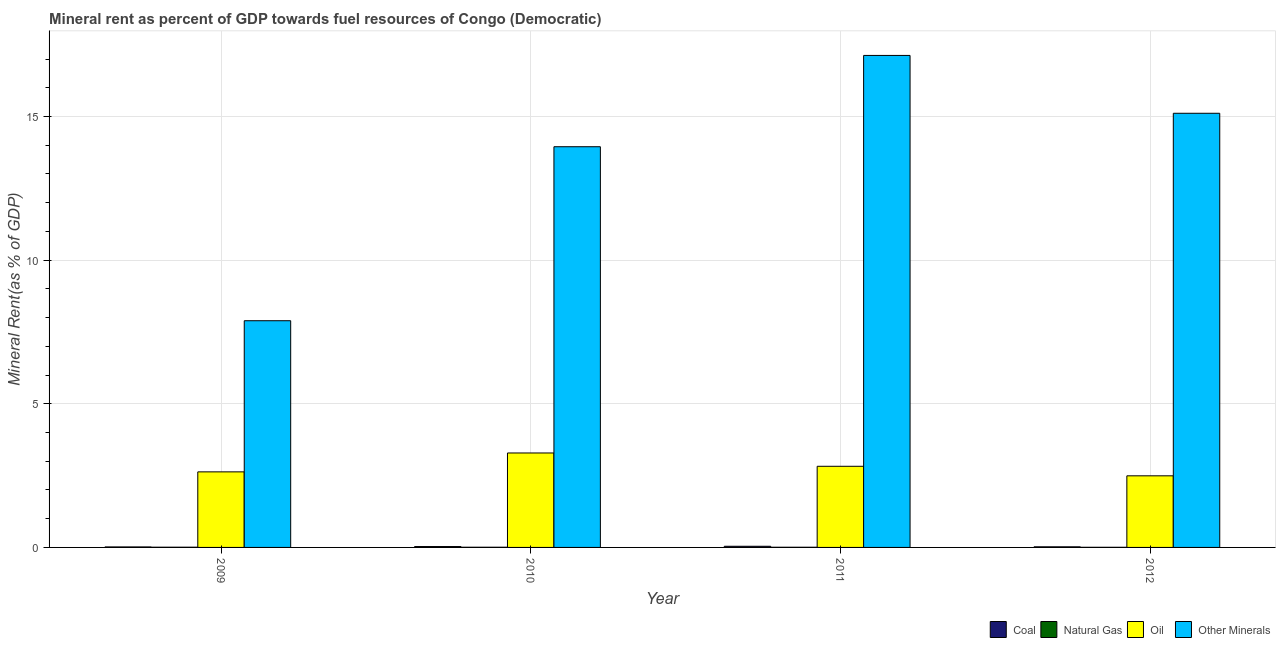How many different coloured bars are there?
Your answer should be very brief. 4. How many groups of bars are there?
Provide a succinct answer. 4. How many bars are there on the 2nd tick from the left?
Your response must be concise. 4. How many bars are there on the 2nd tick from the right?
Your answer should be compact. 4. What is the label of the 1st group of bars from the left?
Offer a terse response. 2009. In how many cases, is the number of bars for a given year not equal to the number of legend labels?
Your response must be concise. 0. What is the oil rent in 2009?
Your response must be concise. 2.63. Across all years, what is the maximum natural gas rent?
Provide a short and direct response. 0.01. Across all years, what is the minimum natural gas rent?
Your response must be concise. 0. In which year was the  rent of other minerals maximum?
Offer a terse response. 2011. What is the total oil rent in the graph?
Your response must be concise. 11.23. What is the difference between the oil rent in 2011 and that in 2012?
Make the answer very short. 0.33. What is the difference between the natural gas rent in 2012 and the oil rent in 2011?
Make the answer very short. -0. What is the average natural gas rent per year?
Your answer should be compact. 0.01. What is the ratio of the natural gas rent in 2010 to that in 2012?
Ensure brevity in your answer.  1.4. What is the difference between the highest and the second highest oil rent?
Give a very brief answer. 0.46. What is the difference between the highest and the lowest natural gas rent?
Provide a short and direct response. 0. Is the sum of the  rent of other minerals in 2009 and 2010 greater than the maximum coal rent across all years?
Offer a terse response. Yes. Is it the case that in every year, the sum of the oil rent and natural gas rent is greater than the sum of  rent of other minerals and coal rent?
Your answer should be compact. Yes. What does the 2nd bar from the left in 2010 represents?
Provide a succinct answer. Natural Gas. What does the 1st bar from the right in 2009 represents?
Offer a terse response. Other Minerals. Are all the bars in the graph horizontal?
Ensure brevity in your answer.  No. What is the difference between two consecutive major ticks on the Y-axis?
Your answer should be very brief. 5. Are the values on the major ticks of Y-axis written in scientific E-notation?
Your answer should be compact. No. Does the graph contain grids?
Offer a very short reply. Yes. How many legend labels are there?
Your answer should be very brief. 4. How are the legend labels stacked?
Your answer should be compact. Horizontal. What is the title of the graph?
Provide a succinct answer. Mineral rent as percent of GDP towards fuel resources of Congo (Democratic). Does "Debt policy" appear as one of the legend labels in the graph?
Provide a short and direct response. No. What is the label or title of the Y-axis?
Your response must be concise. Mineral Rent(as % of GDP). What is the Mineral Rent(as % of GDP) of Coal in 2009?
Make the answer very short. 0.02. What is the Mineral Rent(as % of GDP) in Natural Gas in 2009?
Offer a very short reply. 0.01. What is the Mineral Rent(as % of GDP) in Oil in 2009?
Your response must be concise. 2.63. What is the Mineral Rent(as % of GDP) of Other Minerals in 2009?
Keep it short and to the point. 7.89. What is the Mineral Rent(as % of GDP) in Coal in 2010?
Provide a short and direct response. 0.03. What is the Mineral Rent(as % of GDP) in Natural Gas in 2010?
Keep it short and to the point. 0.01. What is the Mineral Rent(as % of GDP) of Oil in 2010?
Provide a succinct answer. 3.29. What is the Mineral Rent(as % of GDP) in Other Minerals in 2010?
Your answer should be very brief. 13.95. What is the Mineral Rent(as % of GDP) of Coal in 2011?
Provide a succinct answer. 0.04. What is the Mineral Rent(as % of GDP) of Natural Gas in 2011?
Make the answer very short. 0.01. What is the Mineral Rent(as % of GDP) in Oil in 2011?
Keep it short and to the point. 2.82. What is the Mineral Rent(as % of GDP) of Other Minerals in 2011?
Offer a very short reply. 17.13. What is the Mineral Rent(as % of GDP) in Coal in 2012?
Give a very brief answer. 0.02. What is the Mineral Rent(as % of GDP) of Natural Gas in 2012?
Make the answer very short. 0. What is the Mineral Rent(as % of GDP) in Oil in 2012?
Give a very brief answer. 2.49. What is the Mineral Rent(as % of GDP) in Other Minerals in 2012?
Provide a succinct answer. 15.11. Across all years, what is the maximum Mineral Rent(as % of GDP) in Coal?
Offer a very short reply. 0.04. Across all years, what is the maximum Mineral Rent(as % of GDP) in Natural Gas?
Provide a short and direct response. 0.01. Across all years, what is the maximum Mineral Rent(as % of GDP) of Oil?
Make the answer very short. 3.29. Across all years, what is the maximum Mineral Rent(as % of GDP) of Other Minerals?
Your answer should be very brief. 17.13. Across all years, what is the minimum Mineral Rent(as % of GDP) in Coal?
Provide a short and direct response. 0.02. Across all years, what is the minimum Mineral Rent(as % of GDP) in Natural Gas?
Offer a very short reply. 0. Across all years, what is the minimum Mineral Rent(as % of GDP) in Oil?
Offer a very short reply. 2.49. Across all years, what is the minimum Mineral Rent(as % of GDP) in Other Minerals?
Ensure brevity in your answer.  7.89. What is the total Mineral Rent(as % of GDP) in Coal in the graph?
Offer a very short reply. 0.11. What is the total Mineral Rent(as % of GDP) in Natural Gas in the graph?
Provide a succinct answer. 0.02. What is the total Mineral Rent(as % of GDP) of Oil in the graph?
Make the answer very short. 11.23. What is the total Mineral Rent(as % of GDP) of Other Minerals in the graph?
Your answer should be very brief. 54.08. What is the difference between the Mineral Rent(as % of GDP) of Coal in 2009 and that in 2010?
Give a very brief answer. -0.01. What is the difference between the Mineral Rent(as % of GDP) in Natural Gas in 2009 and that in 2010?
Your answer should be compact. 0. What is the difference between the Mineral Rent(as % of GDP) of Oil in 2009 and that in 2010?
Your response must be concise. -0.66. What is the difference between the Mineral Rent(as % of GDP) of Other Minerals in 2009 and that in 2010?
Keep it short and to the point. -6.06. What is the difference between the Mineral Rent(as % of GDP) in Coal in 2009 and that in 2011?
Provide a short and direct response. -0.02. What is the difference between the Mineral Rent(as % of GDP) of Natural Gas in 2009 and that in 2011?
Offer a terse response. 0. What is the difference between the Mineral Rent(as % of GDP) in Oil in 2009 and that in 2011?
Offer a terse response. -0.19. What is the difference between the Mineral Rent(as % of GDP) of Other Minerals in 2009 and that in 2011?
Your answer should be compact. -9.24. What is the difference between the Mineral Rent(as % of GDP) in Coal in 2009 and that in 2012?
Make the answer very short. -0. What is the difference between the Mineral Rent(as % of GDP) in Natural Gas in 2009 and that in 2012?
Ensure brevity in your answer.  0. What is the difference between the Mineral Rent(as % of GDP) in Oil in 2009 and that in 2012?
Provide a succinct answer. 0.14. What is the difference between the Mineral Rent(as % of GDP) in Other Minerals in 2009 and that in 2012?
Make the answer very short. -7.22. What is the difference between the Mineral Rent(as % of GDP) in Coal in 2010 and that in 2011?
Offer a terse response. -0.01. What is the difference between the Mineral Rent(as % of GDP) of Natural Gas in 2010 and that in 2011?
Give a very brief answer. 0. What is the difference between the Mineral Rent(as % of GDP) of Oil in 2010 and that in 2011?
Provide a short and direct response. 0.46. What is the difference between the Mineral Rent(as % of GDP) of Other Minerals in 2010 and that in 2011?
Your response must be concise. -3.18. What is the difference between the Mineral Rent(as % of GDP) of Coal in 2010 and that in 2012?
Give a very brief answer. 0.01. What is the difference between the Mineral Rent(as % of GDP) in Natural Gas in 2010 and that in 2012?
Provide a succinct answer. 0. What is the difference between the Mineral Rent(as % of GDP) in Oil in 2010 and that in 2012?
Make the answer very short. 0.8. What is the difference between the Mineral Rent(as % of GDP) in Other Minerals in 2010 and that in 2012?
Keep it short and to the point. -1.16. What is the difference between the Mineral Rent(as % of GDP) in Coal in 2011 and that in 2012?
Make the answer very short. 0.02. What is the difference between the Mineral Rent(as % of GDP) in Natural Gas in 2011 and that in 2012?
Ensure brevity in your answer.  0. What is the difference between the Mineral Rent(as % of GDP) of Oil in 2011 and that in 2012?
Ensure brevity in your answer.  0.33. What is the difference between the Mineral Rent(as % of GDP) of Other Minerals in 2011 and that in 2012?
Your response must be concise. 2.01. What is the difference between the Mineral Rent(as % of GDP) in Coal in 2009 and the Mineral Rent(as % of GDP) in Natural Gas in 2010?
Your answer should be very brief. 0.01. What is the difference between the Mineral Rent(as % of GDP) of Coal in 2009 and the Mineral Rent(as % of GDP) of Oil in 2010?
Offer a very short reply. -3.27. What is the difference between the Mineral Rent(as % of GDP) of Coal in 2009 and the Mineral Rent(as % of GDP) of Other Minerals in 2010?
Your response must be concise. -13.93. What is the difference between the Mineral Rent(as % of GDP) in Natural Gas in 2009 and the Mineral Rent(as % of GDP) in Oil in 2010?
Keep it short and to the point. -3.28. What is the difference between the Mineral Rent(as % of GDP) in Natural Gas in 2009 and the Mineral Rent(as % of GDP) in Other Minerals in 2010?
Ensure brevity in your answer.  -13.94. What is the difference between the Mineral Rent(as % of GDP) of Oil in 2009 and the Mineral Rent(as % of GDP) of Other Minerals in 2010?
Offer a very short reply. -11.32. What is the difference between the Mineral Rent(as % of GDP) of Coal in 2009 and the Mineral Rent(as % of GDP) of Natural Gas in 2011?
Keep it short and to the point. 0.01. What is the difference between the Mineral Rent(as % of GDP) of Coal in 2009 and the Mineral Rent(as % of GDP) of Oil in 2011?
Make the answer very short. -2.81. What is the difference between the Mineral Rent(as % of GDP) in Coal in 2009 and the Mineral Rent(as % of GDP) in Other Minerals in 2011?
Provide a short and direct response. -17.11. What is the difference between the Mineral Rent(as % of GDP) of Natural Gas in 2009 and the Mineral Rent(as % of GDP) of Oil in 2011?
Provide a succinct answer. -2.82. What is the difference between the Mineral Rent(as % of GDP) of Natural Gas in 2009 and the Mineral Rent(as % of GDP) of Other Minerals in 2011?
Give a very brief answer. -17.12. What is the difference between the Mineral Rent(as % of GDP) of Oil in 2009 and the Mineral Rent(as % of GDP) of Other Minerals in 2011?
Your answer should be very brief. -14.5. What is the difference between the Mineral Rent(as % of GDP) in Coal in 2009 and the Mineral Rent(as % of GDP) in Natural Gas in 2012?
Offer a terse response. 0.01. What is the difference between the Mineral Rent(as % of GDP) of Coal in 2009 and the Mineral Rent(as % of GDP) of Oil in 2012?
Provide a short and direct response. -2.48. What is the difference between the Mineral Rent(as % of GDP) of Coal in 2009 and the Mineral Rent(as % of GDP) of Other Minerals in 2012?
Your answer should be compact. -15.1. What is the difference between the Mineral Rent(as % of GDP) in Natural Gas in 2009 and the Mineral Rent(as % of GDP) in Oil in 2012?
Ensure brevity in your answer.  -2.49. What is the difference between the Mineral Rent(as % of GDP) in Natural Gas in 2009 and the Mineral Rent(as % of GDP) in Other Minerals in 2012?
Your answer should be compact. -15.11. What is the difference between the Mineral Rent(as % of GDP) in Oil in 2009 and the Mineral Rent(as % of GDP) in Other Minerals in 2012?
Your answer should be compact. -12.48. What is the difference between the Mineral Rent(as % of GDP) in Coal in 2010 and the Mineral Rent(as % of GDP) in Natural Gas in 2011?
Make the answer very short. 0.02. What is the difference between the Mineral Rent(as % of GDP) in Coal in 2010 and the Mineral Rent(as % of GDP) in Oil in 2011?
Make the answer very short. -2.79. What is the difference between the Mineral Rent(as % of GDP) in Coal in 2010 and the Mineral Rent(as % of GDP) in Other Minerals in 2011?
Your response must be concise. -17.1. What is the difference between the Mineral Rent(as % of GDP) in Natural Gas in 2010 and the Mineral Rent(as % of GDP) in Oil in 2011?
Offer a very short reply. -2.82. What is the difference between the Mineral Rent(as % of GDP) in Natural Gas in 2010 and the Mineral Rent(as % of GDP) in Other Minerals in 2011?
Your answer should be compact. -17.12. What is the difference between the Mineral Rent(as % of GDP) in Oil in 2010 and the Mineral Rent(as % of GDP) in Other Minerals in 2011?
Keep it short and to the point. -13.84. What is the difference between the Mineral Rent(as % of GDP) of Coal in 2010 and the Mineral Rent(as % of GDP) of Natural Gas in 2012?
Provide a short and direct response. 0.03. What is the difference between the Mineral Rent(as % of GDP) in Coal in 2010 and the Mineral Rent(as % of GDP) in Oil in 2012?
Offer a very short reply. -2.46. What is the difference between the Mineral Rent(as % of GDP) in Coal in 2010 and the Mineral Rent(as % of GDP) in Other Minerals in 2012?
Ensure brevity in your answer.  -15.08. What is the difference between the Mineral Rent(as % of GDP) of Natural Gas in 2010 and the Mineral Rent(as % of GDP) of Oil in 2012?
Offer a very short reply. -2.49. What is the difference between the Mineral Rent(as % of GDP) of Natural Gas in 2010 and the Mineral Rent(as % of GDP) of Other Minerals in 2012?
Keep it short and to the point. -15.11. What is the difference between the Mineral Rent(as % of GDP) of Oil in 2010 and the Mineral Rent(as % of GDP) of Other Minerals in 2012?
Provide a short and direct response. -11.83. What is the difference between the Mineral Rent(as % of GDP) of Coal in 2011 and the Mineral Rent(as % of GDP) of Natural Gas in 2012?
Give a very brief answer. 0.04. What is the difference between the Mineral Rent(as % of GDP) of Coal in 2011 and the Mineral Rent(as % of GDP) of Oil in 2012?
Give a very brief answer. -2.45. What is the difference between the Mineral Rent(as % of GDP) in Coal in 2011 and the Mineral Rent(as % of GDP) in Other Minerals in 2012?
Make the answer very short. -15.07. What is the difference between the Mineral Rent(as % of GDP) in Natural Gas in 2011 and the Mineral Rent(as % of GDP) in Oil in 2012?
Provide a short and direct response. -2.49. What is the difference between the Mineral Rent(as % of GDP) in Natural Gas in 2011 and the Mineral Rent(as % of GDP) in Other Minerals in 2012?
Offer a terse response. -15.11. What is the difference between the Mineral Rent(as % of GDP) of Oil in 2011 and the Mineral Rent(as % of GDP) of Other Minerals in 2012?
Make the answer very short. -12.29. What is the average Mineral Rent(as % of GDP) in Coal per year?
Offer a terse response. 0.03. What is the average Mineral Rent(as % of GDP) in Natural Gas per year?
Offer a terse response. 0.01. What is the average Mineral Rent(as % of GDP) in Oil per year?
Keep it short and to the point. 2.81. What is the average Mineral Rent(as % of GDP) in Other Minerals per year?
Keep it short and to the point. 13.52. In the year 2009, what is the difference between the Mineral Rent(as % of GDP) of Coal and Mineral Rent(as % of GDP) of Natural Gas?
Give a very brief answer. 0.01. In the year 2009, what is the difference between the Mineral Rent(as % of GDP) of Coal and Mineral Rent(as % of GDP) of Oil?
Your response must be concise. -2.61. In the year 2009, what is the difference between the Mineral Rent(as % of GDP) in Coal and Mineral Rent(as % of GDP) in Other Minerals?
Provide a succinct answer. -7.87. In the year 2009, what is the difference between the Mineral Rent(as % of GDP) of Natural Gas and Mineral Rent(as % of GDP) of Oil?
Your response must be concise. -2.62. In the year 2009, what is the difference between the Mineral Rent(as % of GDP) in Natural Gas and Mineral Rent(as % of GDP) in Other Minerals?
Provide a short and direct response. -7.88. In the year 2009, what is the difference between the Mineral Rent(as % of GDP) in Oil and Mineral Rent(as % of GDP) in Other Minerals?
Your response must be concise. -5.26. In the year 2010, what is the difference between the Mineral Rent(as % of GDP) in Coal and Mineral Rent(as % of GDP) in Natural Gas?
Offer a very short reply. 0.02. In the year 2010, what is the difference between the Mineral Rent(as % of GDP) of Coal and Mineral Rent(as % of GDP) of Oil?
Your answer should be compact. -3.26. In the year 2010, what is the difference between the Mineral Rent(as % of GDP) in Coal and Mineral Rent(as % of GDP) in Other Minerals?
Your response must be concise. -13.92. In the year 2010, what is the difference between the Mineral Rent(as % of GDP) in Natural Gas and Mineral Rent(as % of GDP) in Oil?
Your answer should be very brief. -3.28. In the year 2010, what is the difference between the Mineral Rent(as % of GDP) in Natural Gas and Mineral Rent(as % of GDP) in Other Minerals?
Provide a short and direct response. -13.94. In the year 2010, what is the difference between the Mineral Rent(as % of GDP) in Oil and Mineral Rent(as % of GDP) in Other Minerals?
Keep it short and to the point. -10.66. In the year 2011, what is the difference between the Mineral Rent(as % of GDP) in Coal and Mineral Rent(as % of GDP) in Natural Gas?
Provide a short and direct response. 0.03. In the year 2011, what is the difference between the Mineral Rent(as % of GDP) of Coal and Mineral Rent(as % of GDP) of Oil?
Provide a short and direct response. -2.78. In the year 2011, what is the difference between the Mineral Rent(as % of GDP) in Coal and Mineral Rent(as % of GDP) in Other Minerals?
Make the answer very short. -17.09. In the year 2011, what is the difference between the Mineral Rent(as % of GDP) in Natural Gas and Mineral Rent(as % of GDP) in Oil?
Keep it short and to the point. -2.82. In the year 2011, what is the difference between the Mineral Rent(as % of GDP) of Natural Gas and Mineral Rent(as % of GDP) of Other Minerals?
Your answer should be very brief. -17.12. In the year 2011, what is the difference between the Mineral Rent(as % of GDP) of Oil and Mineral Rent(as % of GDP) of Other Minerals?
Provide a succinct answer. -14.3. In the year 2012, what is the difference between the Mineral Rent(as % of GDP) in Coal and Mineral Rent(as % of GDP) in Natural Gas?
Your response must be concise. 0.02. In the year 2012, what is the difference between the Mineral Rent(as % of GDP) in Coal and Mineral Rent(as % of GDP) in Oil?
Give a very brief answer. -2.47. In the year 2012, what is the difference between the Mineral Rent(as % of GDP) in Coal and Mineral Rent(as % of GDP) in Other Minerals?
Your answer should be very brief. -15.09. In the year 2012, what is the difference between the Mineral Rent(as % of GDP) in Natural Gas and Mineral Rent(as % of GDP) in Oil?
Your answer should be very brief. -2.49. In the year 2012, what is the difference between the Mineral Rent(as % of GDP) in Natural Gas and Mineral Rent(as % of GDP) in Other Minerals?
Your answer should be very brief. -15.11. In the year 2012, what is the difference between the Mineral Rent(as % of GDP) of Oil and Mineral Rent(as % of GDP) of Other Minerals?
Your response must be concise. -12.62. What is the ratio of the Mineral Rent(as % of GDP) in Coal in 2009 to that in 2010?
Ensure brevity in your answer.  0.56. What is the ratio of the Mineral Rent(as % of GDP) of Natural Gas in 2009 to that in 2010?
Your response must be concise. 1.2. What is the ratio of the Mineral Rent(as % of GDP) in Oil in 2009 to that in 2010?
Give a very brief answer. 0.8. What is the ratio of the Mineral Rent(as % of GDP) in Other Minerals in 2009 to that in 2010?
Offer a terse response. 0.57. What is the ratio of the Mineral Rent(as % of GDP) in Coal in 2009 to that in 2011?
Ensure brevity in your answer.  0.42. What is the ratio of the Mineral Rent(as % of GDP) of Natural Gas in 2009 to that in 2011?
Ensure brevity in your answer.  1.25. What is the ratio of the Mineral Rent(as % of GDP) of Oil in 2009 to that in 2011?
Provide a short and direct response. 0.93. What is the ratio of the Mineral Rent(as % of GDP) in Other Minerals in 2009 to that in 2011?
Your response must be concise. 0.46. What is the ratio of the Mineral Rent(as % of GDP) in Coal in 2009 to that in 2012?
Provide a short and direct response. 0.82. What is the ratio of the Mineral Rent(as % of GDP) in Natural Gas in 2009 to that in 2012?
Offer a terse response. 1.67. What is the ratio of the Mineral Rent(as % of GDP) in Oil in 2009 to that in 2012?
Keep it short and to the point. 1.06. What is the ratio of the Mineral Rent(as % of GDP) in Other Minerals in 2009 to that in 2012?
Your answer should be very brief. 0.52. What is the ratio of the Mineral Rent(as % of GDP) in Coal in 2010 to that in 2011?
Your answer should be very brief. 0.76. What is the ratio of the Mineral Rent(as % of GDP) of Natural Gas in 2010 to that in 2011?
Provide a short and direct response. 1.05. What is the ratio of the Mineral Rent(as % of GDP) of Oil in 2010 to that in 2011?
Your answer should be very brief. 1.16. What is the ratio of the Mineral Rent(as % of GDP) in Other Minerals in 2010 to that in 2011?
Keep it short and to the point. 0.81. What is the ratio of the Mineral Rent(as % of GDP) of Coal in 2010 to that in 2012?
Offer a very short reply. 1.46. What is the ratio of the Mineral Rent(as % of GDP) of Natural Gas in 2010 to that in 2012?
Ensure brevity in your answer.  1.4. What is the ratio of the Mineral Rent(as % of GDP) in Oil in 2010 to that in 2012?
Ensure brevity in your answer.  1.32. What is the ratio of the Mineral Rent(as % of GDP) in Other Minerals in 2010 to that in 2012?
Offer a very short reply. 0.92. What is the ratio of the Mineral Rent(as % of GDP) of Coal in 2011 to that in 2012?
Your answer should be compact. 1.93. What is the ratio of the Mineral Rent(as % of GDP) of Natural Gas in 2011 to that in 2012?
Ensure brevity in your answer.  1.33. What is the ratio of the Mineral Rent(as % of GDP) of Oil in 2011 to that in 2012?
Offer a very short reply. 1.13. What is the ratio of the Mineral Rent(as % of GDP) of Other Minerals in 2011 to that in 2012?
Keep it short and to the point. 1.13. What is the difference between the highest and the second highest Mineral Rent(as % of GDP) of Coal?
Your response must be concise. 0.01. What is the difference between the highest and the second highest Mineral Rent(as % of GDP) in Natural Gas?
Provide a succinct answer. 0. What is the difference between the highest and the second highest Mineral Rent(as % of GDP) in Oil?
Make the answer very short. 0.46. What is the difference between the highest and the second highest Mineral Rent(as % of GDP) of Other Minerals?
Provide a short and direct response. 2.01. What is the difference between the highest and the lowest Mineral Rent(as % of GDP) of Coal?
Ensure brevity in your answer.  0.02. What is the difference between the highest and the lowest Mineral Rent(as % of GDP) of Natural Gas?
Offer a terse response. 0. What is the difference between the highest and the lowest Mineral Rent(as % of GDP) in Oil?
Your answer should be very brief. 0.8. What is the difference between the highest and the lowest Mineral Rent(as % of GDP) in Other Minerals?
Your answer should be compact. 9.24. 